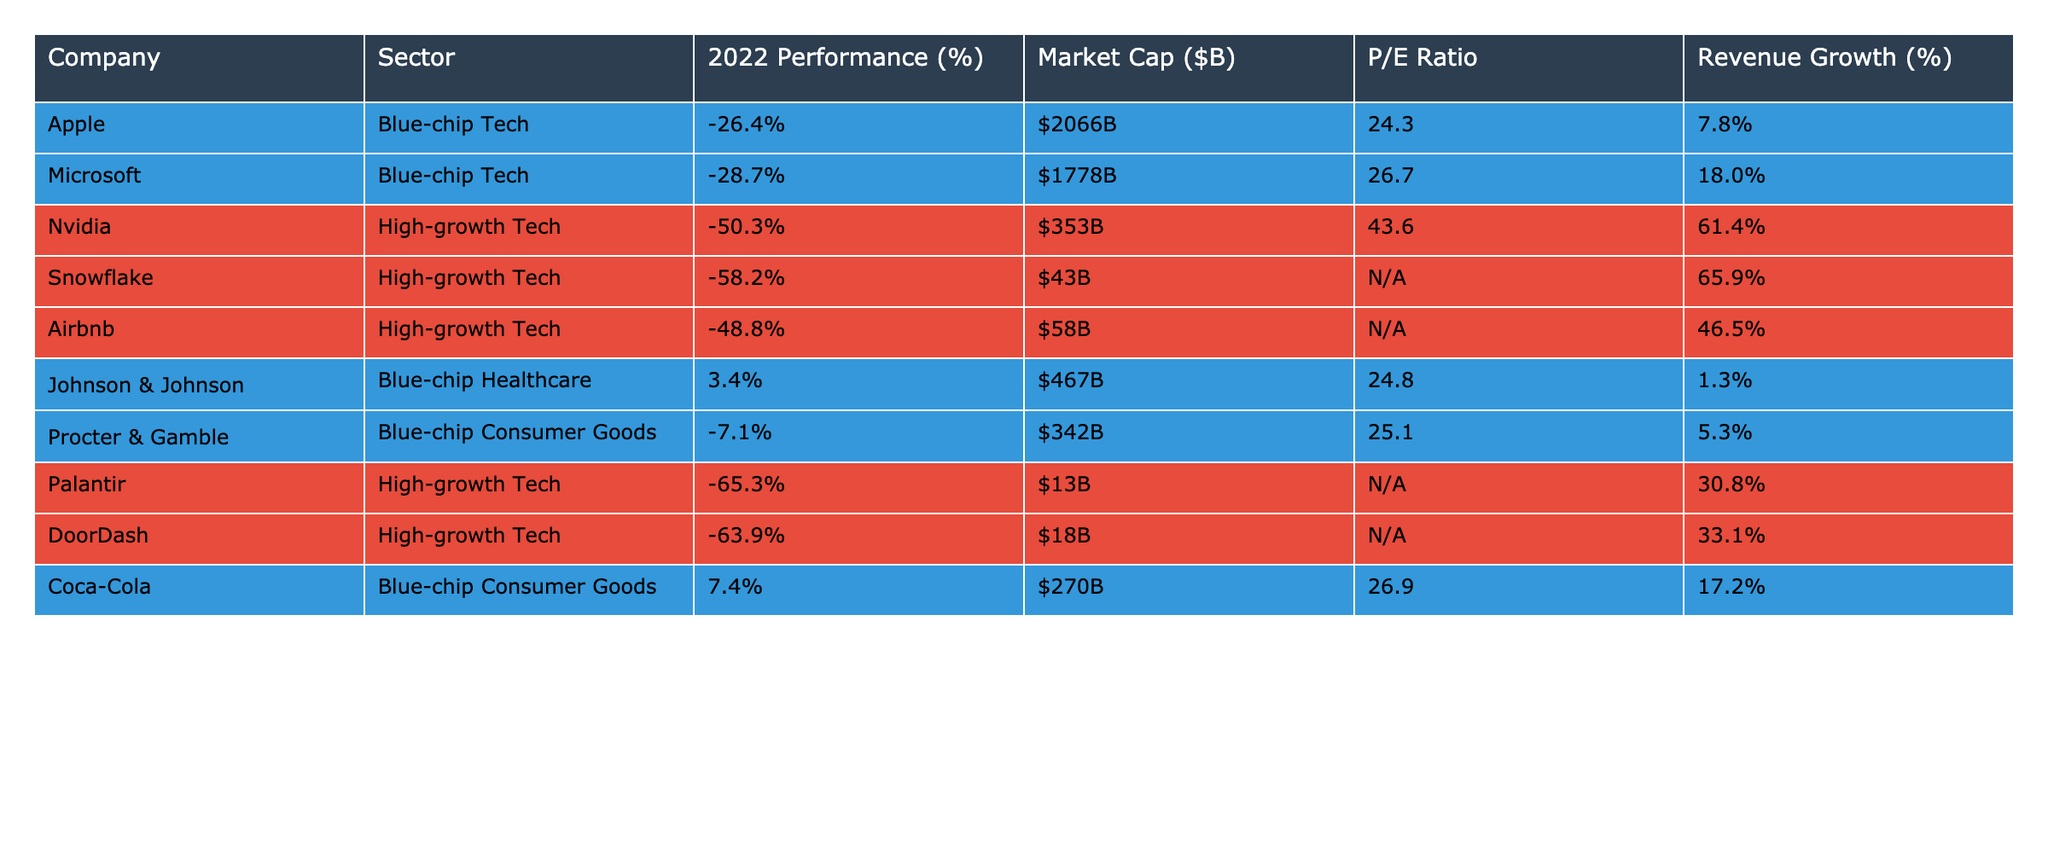What was the performance percentage of Nvidia in 2022? The table shows that Nvidia had a performance of -50.3% in 2022.
Answer: -50.3% Which blue-chip company had the highest market capitalization? According to the table, Apple had the highest market capitalization at $2066B among blue-chip companies.
Answer: $2066B What is the average market capitalization of the high-growth tech startups listed? The market capitalizations of Nvidia ($353B), Snowflake ($43B), Airbnb ($58B), Palantir ($13B), and DoorDash ($18B) sum to $485B, which is divided by 5 companies, resulting in an average of $97B.
Answer: $97B Did any blue-chip companies show a positive performance in 2022? Yes, Johnson & Johnson and Coca-Cola had positive performances of 3.4% and 7.4%, respectively.
Answer: Yes If we consider only the Tech sector, what is the total revenue growth percentage of the companies listed? The revenue growth percentages are 7.8% for Apple, 18.0% for Microsoft, 61.4% for Nvidia, 65.9% for Snowflake, 46.5% for Airbnb, and 30.8% for Palantir. Adding these gives a total of 230.4%, which when divided by the 6 companies results in an average of 38.4%.
Answer: 38.4% Which high-growth tech company had the worst performance in 2022? Palantir had the worst performance in 2022 with a decline of -65.3%.
Answer: -65.3% Is the P/E Ratio available for all companies in the table? No, the P/E Ratio is not available (labeled as “N/A”) for some high-growth tech startups: Snowflake, Airbnb, Palantir, and DoorDash.
Answer: No What is the revenue growth percentage of the most successful high-growth tech startup? The highest revenue growth percentage among high-growth tech startups is 65.9% for Snowflake.
Answer: 65.9% Which sector, blue-chip or high-growth tech, had the most companies with negative performance in 2022? There are 4 high-growth tech companies (Nvidia, Snowflake, Airbnb, Palantir, and DoorDash) with negative performance versus 3 blue-chip companies (Apple, Microsoft, and Procter & Gamble). Therefore, high-growth tech had more.
Answer: High-growth tech Calculate the average P/E Ratio of blue-chip companies in the table. The P/E Ratios of Apple (24.3), Microsoft (26.7), Johnson & Johnson (24.8), Procter & Gamble (25.1), and Coca-Cola (26.9) sum to 127.8, divided by 5 gives an average of 25.56.
Answer: 25.6 